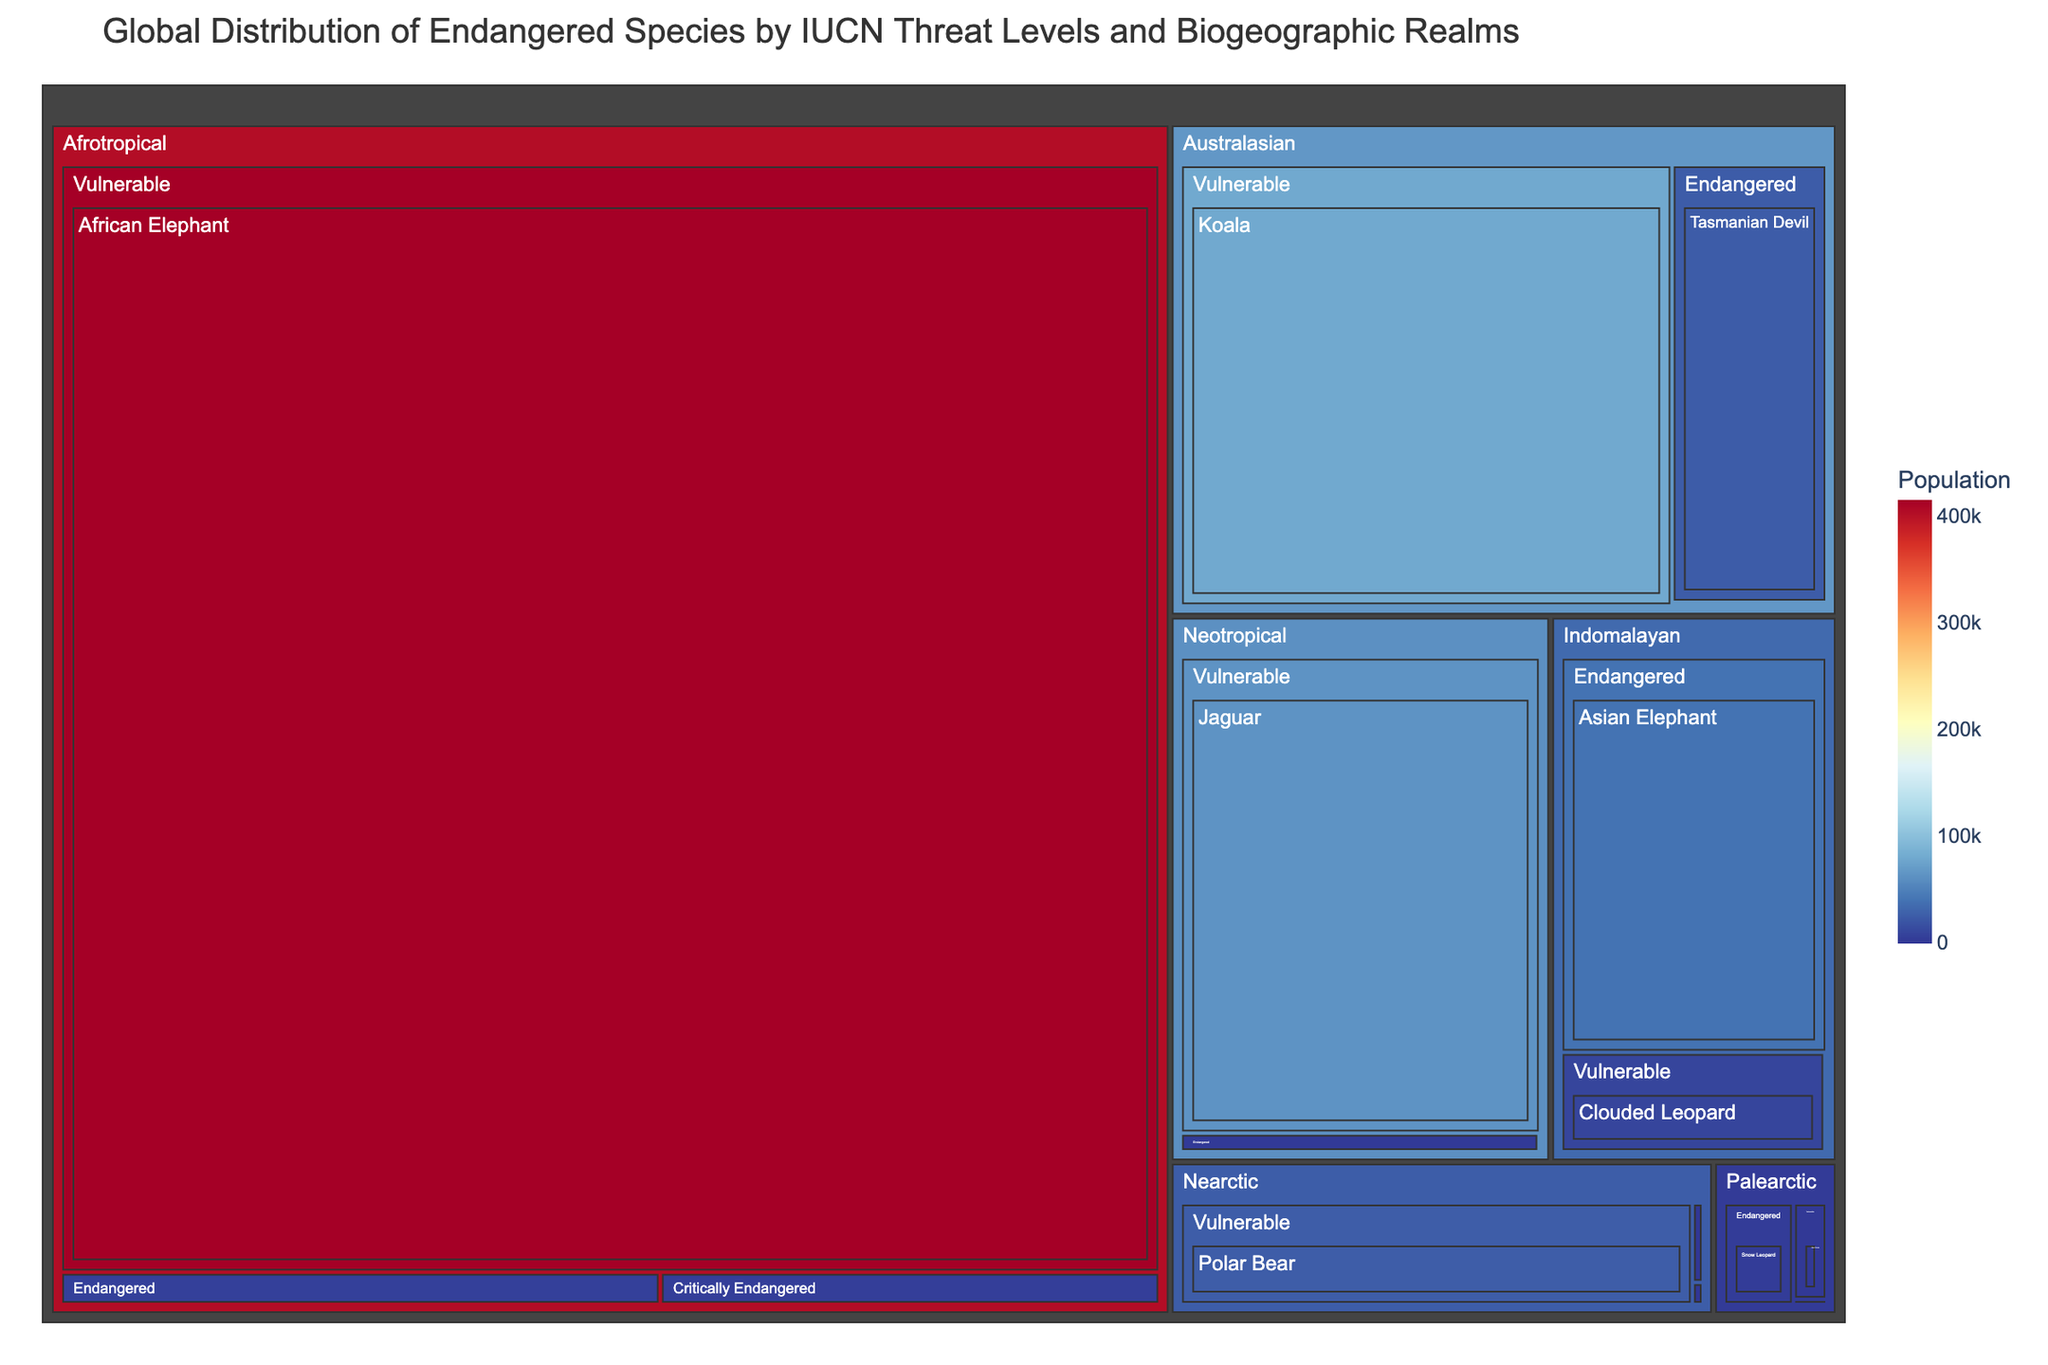What's the title of the figure? The title is usually found at the top of the figure. It summarizes the main message of the figure in one sentence.
Answer: Global Distribution of Endangered Species by IUCN Threat Levels and Biogeographic Realms Which realm has the species with the highest population? To find this, look for the largest box in the treemap, as it visually represents the highest population value. The largest box corresponds to the Afrotropical realm with the African Elephant.
Answer: Afrotropical What is the population of the critically endangered Vaquita? Locate the Neotropical realm, then find the box labeled "Critically Endangered" and "Vaquita." The population is displayed inside or when you hover over the box.
Answer: 10 How many critically endangered species are shown in the Australasian realm? Look in the Australasian realm section of the treemap and count the boxes labeled as "Critically Endangered."
Answer: 1 Which biogeographic realm has the most diverse range of species categories? To determine this, count the number of unique species categories within each realm section of the treemap. The realm with the highest count is the most diverse.
Answer: Indomalayan How many species are endangered in the Nearctic realm? Find the Nearctic realm section and count the boxes labeled "Endangered."
Answer: 1 species (Florida Panther) Compare the population of the African Elephant and the Koala. Which one has a greater population? Locate the boxes for the African Elephant in the Afrotropical realm and the Koala in the Australasian realm. Compare the numbers displayed for each.
Answer: African Elephant Which realm has the smallest critically endangered population overall? Sum the populations of critically endangered species for each realm by looking at their respective boxes. The realm with the smallest total is the Neotropical realm because the Vaquita has the smallest population.
Answer: Neotropical How does the population of the endangered Asian Elephant compare to the vulnerable Koala? Locate the boxes for the Asian Elephant in the Indomalayan realm and the Koala in the Australasian realm. Compare the numbers displayed for each.
Answer: Asian Elephant has a smaller population than Koala What is the average population of the species labeled as "Vulnerable" in the Neotropical realm? Locate the boxes labeled "Vulnerable" in the Neotropical realm. Sum their populations and divide by the number of species in this category. (64000 / 1)
Answer: 64000 